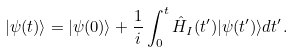Convert formula to latex. <formula><loc_0><loc_0><loc_500><loc_500>| \psi ( t ) \rangle = | \psi ( 0 ) \rangle + \frac { 1 } { i } \int ^ { t } _ { 0 } \hat { H } _ { I } ( t ^ { \prime } ) | \psi ( t ^ { \prime } ) \rangle d t ^ { \prime } .</formula> 